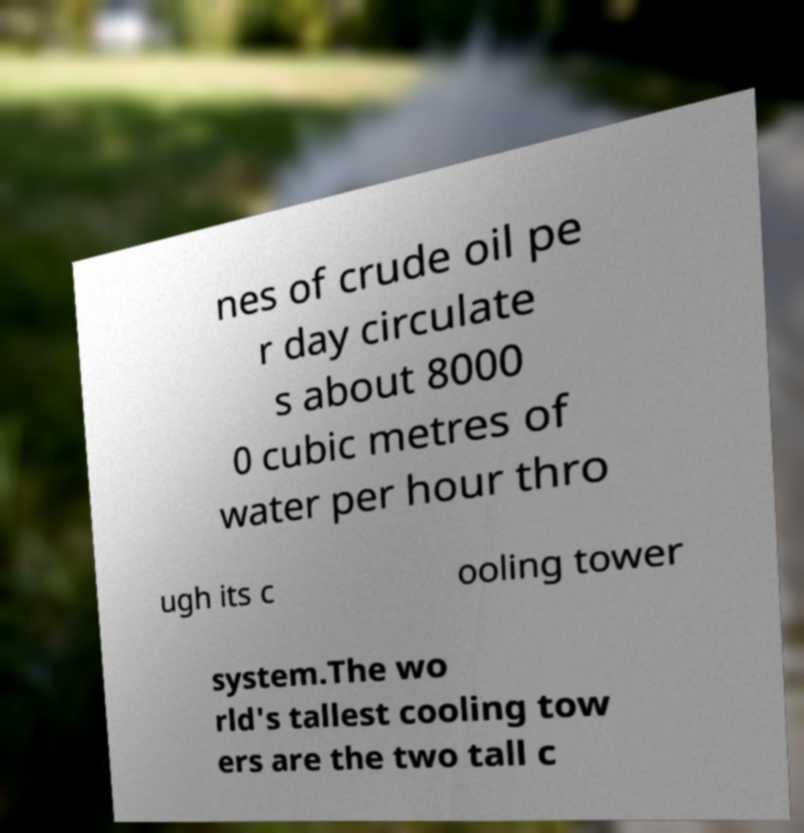Could you assist in decoding the text presented in this image and type it out clearly? nes of crude oil pe r day circulate s about 8000 0 cubic metres of water per hour thro ugh its c ooling tower system.The wo rld's tallest cooling tow ers are the two tall c 